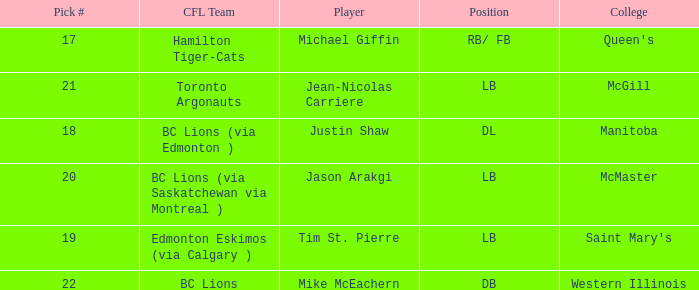What position is Justin Shaw in? DL. 